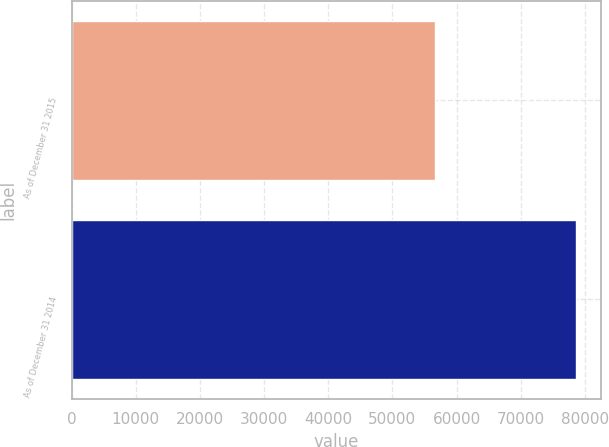Convert chart to OTSL. <chart><loc_0><loc_0><loc_500><loc_500><bar_chart><fcel>As of December 31 2015<fcel>As of December 31 2014<nl><fcel>56631<fcel>78633<nl></chart> 